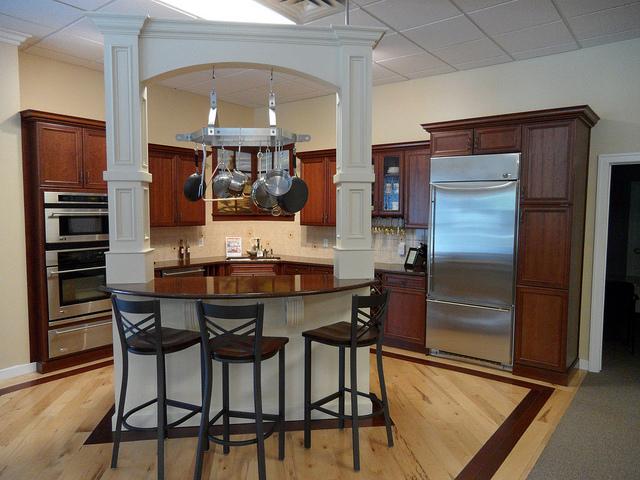Is this safe?
Quick response, please. Yes. Does this kitchen look clean?
Keep it brief. Yes. What color is the fridge?
Short answer required. Silver. Is this table and chair outside?
Short answer required. No. Is the stove new?
Give a very brief answer. Yes. What is the large brown object?
Keep it brief. Cabinet. What type of chairs are these?
Give a very brief answer. Stools. Which room is this?
Keep it brief. Kitchen. How many chairs are there?
Short answer required. 3. Is there a place to shower here?
Concise answer only. No. What kind of chair is this?
Short answer required. Bar stool. Is the cushion on the chair cracked?
Be succinct. No. How old is this house?
Concise answer only. New. Is this room spacious?
Concise answer only. Yes. Is it disgusting?
Give a very brief answer. No. Is there a microwave in this kitchen?
Give a very brief answer. No. Is this room modern?
Be succinct. Yes. Does this room need a remodel?
Give a very brief answer. No. What room is this?
Concise answer only. Kitchen. What is the finish on the appliances?
Short answer required. Stainless steel. IS there a bag in the picture?
Concise answer only. No. How many chairs are shown?
Give a very brief answer. 3. 